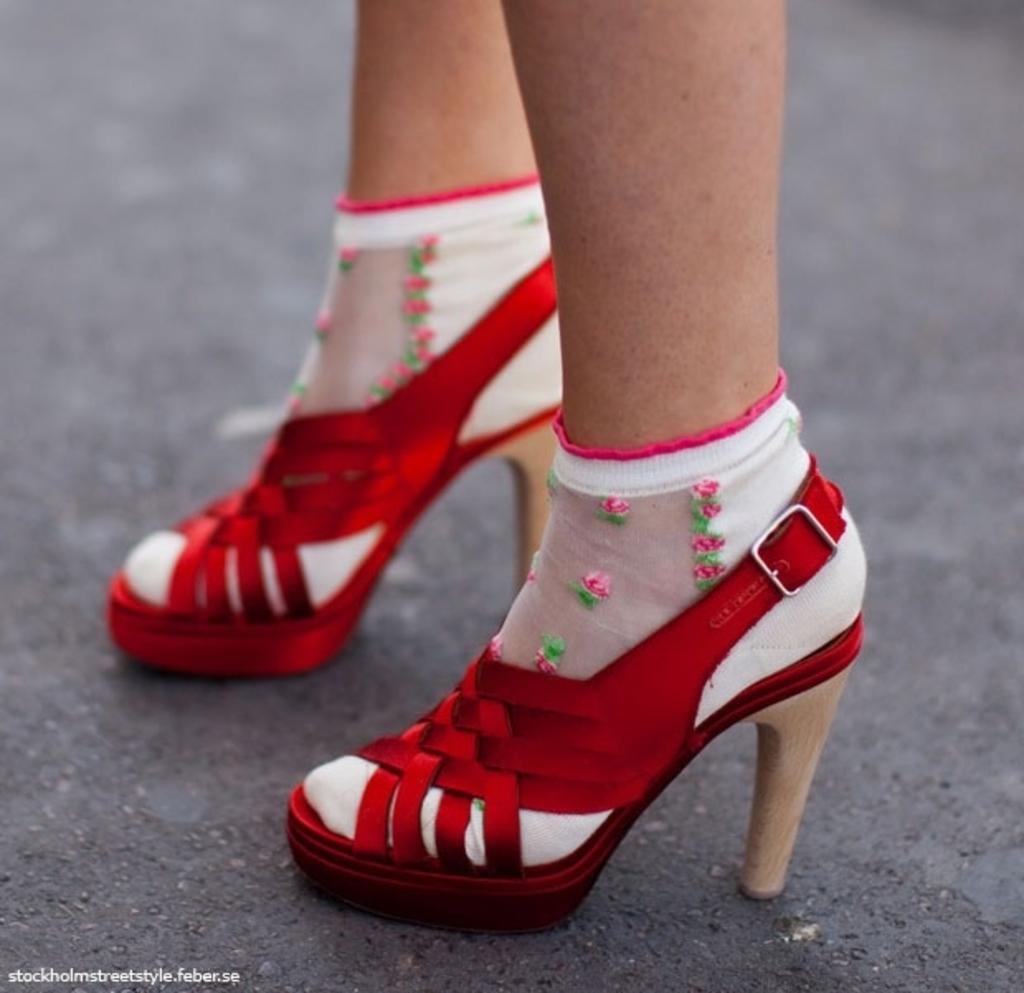Could you give a brief overview of what you see in this image? In this image we can see legs of a person on the road, worn footwear to the legs and at the bottom there is a text on the image. 